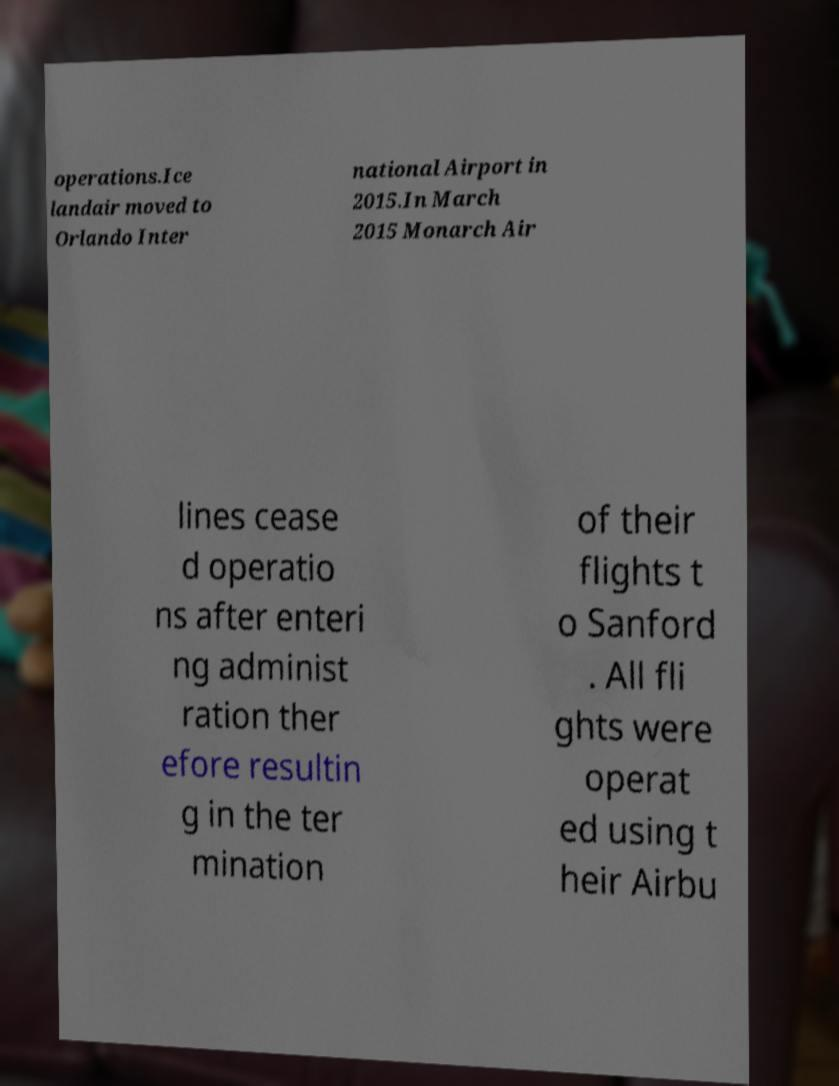Can you accurately transcribe the text from the provided image for me? operations.Ice landair moved to Orlando Inter national Airport in 2015.In March 2015 Monarch Air lines cease d operatio ns after enteri ng administ ration ther efore resultin g in the ter mination of their flights t o Sanford . All fli ghts were operat ed using t heir Airbu 